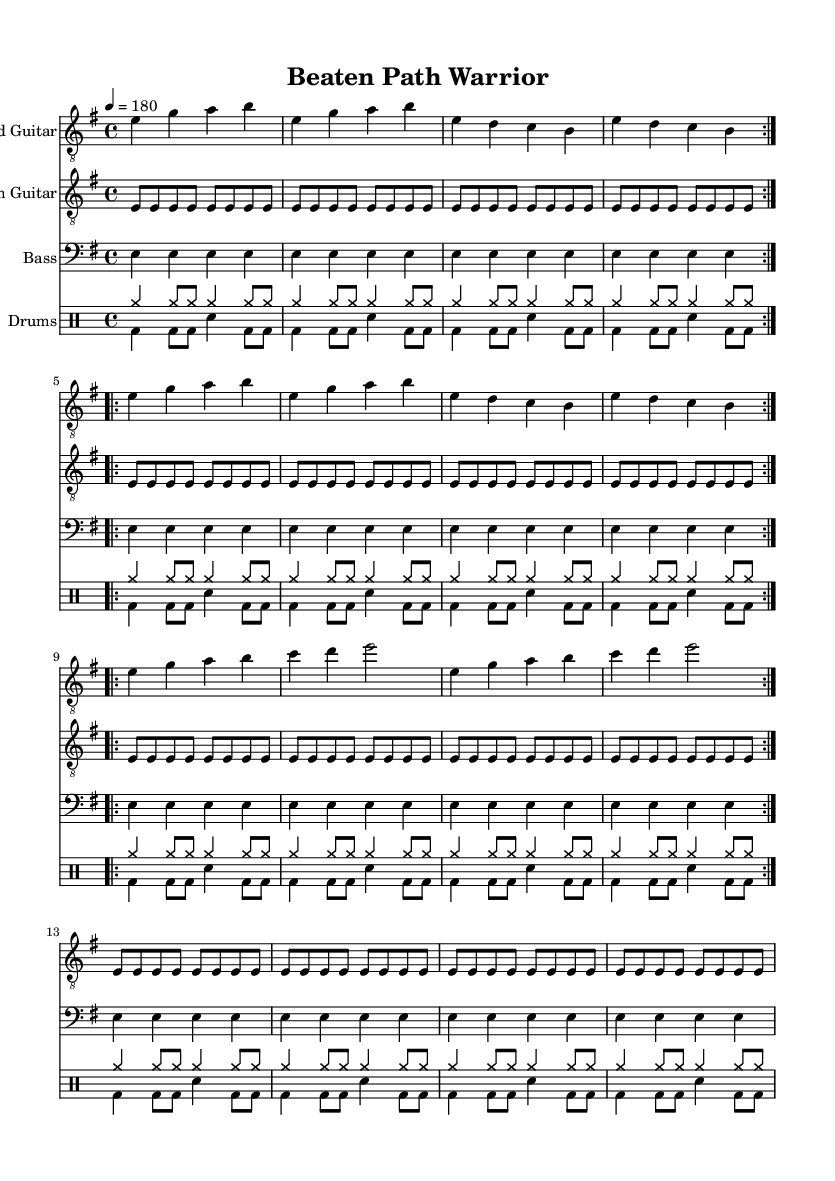What is the key signature of this music? The key signature is E minor, which contains one sharp (F#). This can be determined by looking at the global settings in the code where "e \minor" is specified.
Answer: E minor What is the time signature of this music? The time signature is 4/4, as indicated by the section labeled "\time 4/4" in the global settings of the code.
Answer: 4/4 What is the tempo of the piece? The tempo is set at 180 beats per minute, denoted by "\tempo 4 = 180" in the global settings. This shows how fast the music should be played.
Answer: 180 How many times is the lead guitar melody repeated in the first section? The lead guitar melody is repeated 2 times in three separate sections, as indicated by "\repeat volta 2" for each of them. Therefore, it sums up to a total of 6 repetitions.
Answer: 6 What type of music is this piece classified as? This piece is classified as Thrash Metal, indicated by the lyrics and structure that focus on fast tempos, aggressive riffs, and thematic content related to outsmarting tourist traps and overpriced attractions, typical of the genre.
Answer: Thrash Metal What is the primary theme expressed in the lyrics? The primary theme is about being wary of overpriced traps and how to outsmart crowds, as detailed in the verses and chorus of the lyrics. The lyrics reflect a traveler's standpoint seeking to avoid tourist pitfalls, which resonates with the concept of "Beaten Path Warrior."
Answer: Outsmarting tourist traps 